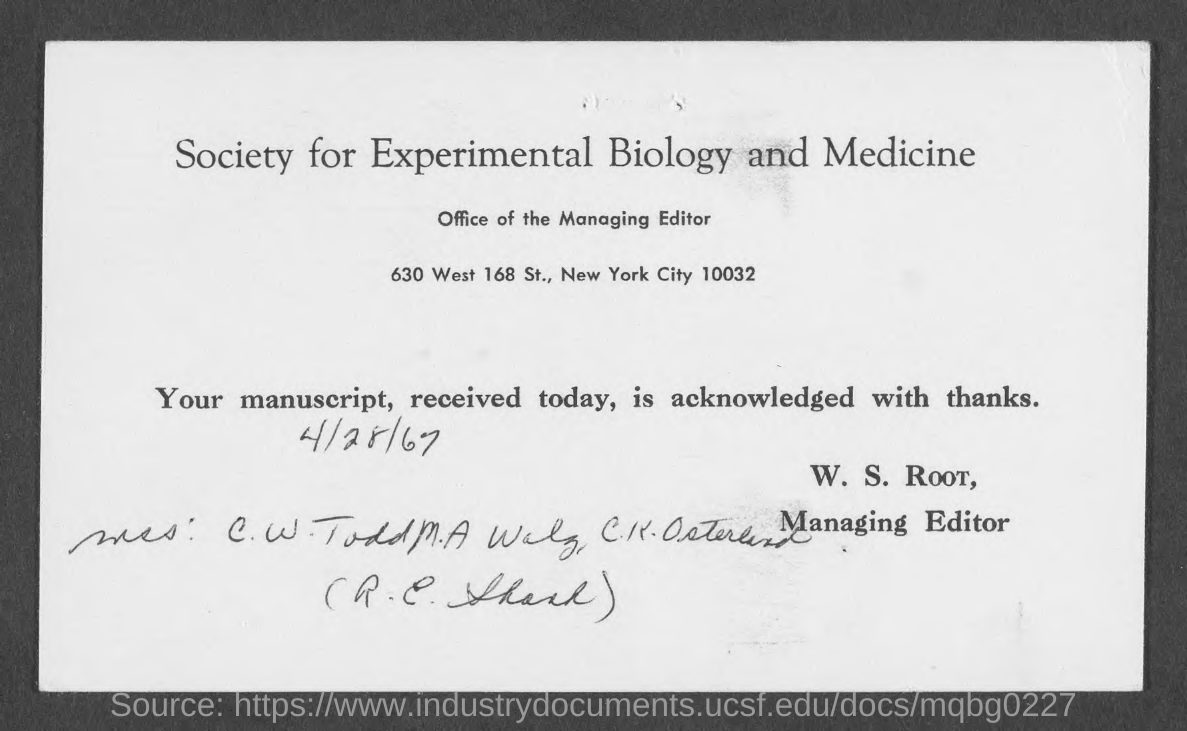Specify some key components in this picture. The received date of the manuscript is April 28th, 1967. 